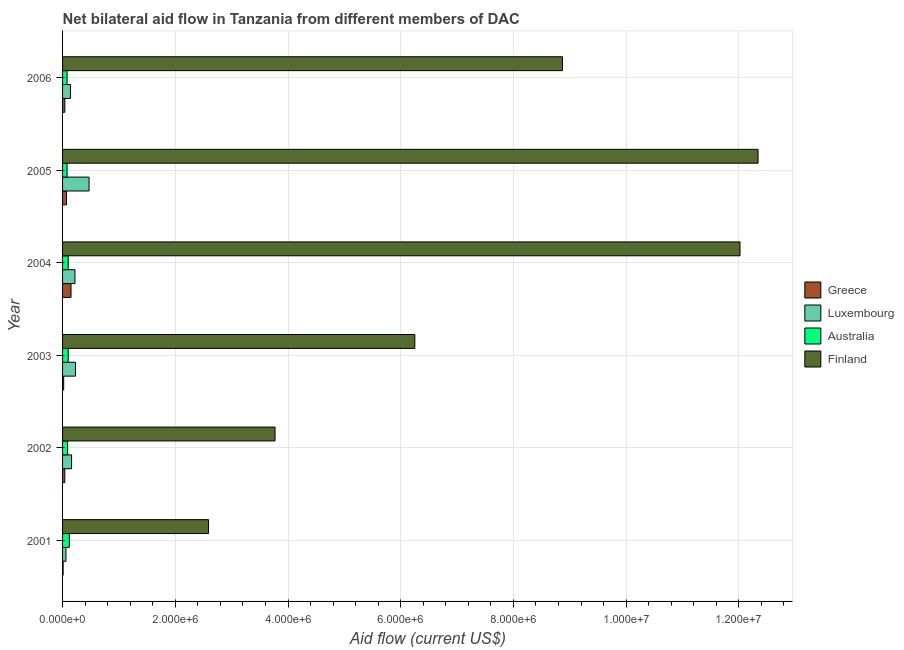Are the number of bars per tick equal to the number of legend labels?
Keep it short and to the point. Yes. Are the number of bars on each tick of the Y-axis equal?
Give a very brief answer. Yes. What is the amount of aid given by finland in 2005?
Keep it short and to the point. 1.23e+07. Across all years, what is the maximum amount of aid given by australia?
Your answer should be very brief. 1.20e+05. Across all years, what is the minimum amount of aid given by greece?
Provide a succinct answer. 10000. In which year was the amount of aid given by australia minimum?
Make the answer very short. 2005. What is the total amount of aid given by luxembourg in the graph?
Provide a short and direct response. 1.28e+06. What is the difference between the amount of aid given by finland in 2003 and that in 2005?
Provide a short and direct response. -6.09e+06. What is the difference between the amount of aid given by finland in 2004 and the amount of aid given by luxembourg in 2003?
Your answer should be compact. 1.18e+07. What is the average amount of aid given by luxembourg per year?
Your response must be concise. 2.13e+05. In the year 2001, what is the difference between the amount of aid given by finland and amount of aid given by luxembourg?
Offer a very short reply. 2.53e+06. What is the ratio of the amount of aid given by luxembourg in 2002 to that in 2003?
Your answer should be very brief. 0.7. Is the difference between the amount of aid given by greece in 2001 and 2005 greater than the difference between the amount of aid given by luxembourg in 2001 and 2005?
Your response must be concise. Yes. What is the difference between the highest and the second highest amount of aid given by luxembourg?
Make the answer very short. 2.40e+05. What is the difference between the highest and the lowest amount of aid given by luxembourg?
Your answer should be compact. 4.10e+05. In how many years, is the amount of aid given by greece greater than the average amount of aid given by greece taken over all years?
Offer a terse response. 2. Is the sum of the amount of aid given by australia in 2001 and 2004 greater than the maximum amount of aid given by luxembourg across all years?
Offer a very short reply. No. What does the 3rd bar from the top in 2004 represents?
Provide a short and direct response. Luxembourg. Is it the case that in every year, the sum of the amount of aid given by greece and amount of aid given by luxembourg is greater than the amount of aid given by australia?
Offer a terse response. No. Are all the bars in the graph horizontal?
Your answer should be very brief. Yes. Does the graph contain any zero values?
Offer a terse response. No. Does the graph contain grids?
Provide a short and direct response. Yes. How many legend labels are there?
Your answer should be compact. 4. How are the legend labels stacked?
Your response must be concise. Vertical. What is the title of the graph?
Your answer should be compact. Net bilateral aid flow in Tanzania from different members of DAC. What is the label or title of the X-axis?
Your answer should be compact. Aid flow (current US$). What is the Aid flow (current US$) in Australia in 2001?
Offer a very short reply. 1.20e+05. What is the Aid flow (current US$) of Finland in 2001?
Ensure brevity in your answer.  2.59e+06. What is the Aid flow (current US$) of Luxembourg in 2002?
Ensure brevity in your answer.  1.60e+05. What is the Aid flow (current US$) in Finland in 2002?
Your answer should be very brief. 3.77e+06. What is the Aid flow (current US$) in Luxembourg in 2003?
Offer a terse response. 2.30e+05. What is the Aid flow (current US$) of Australia in 2003?
Provide a short and direct response. 1.00e+05. What is the Aid flow (current US$) in Finland in 2003?
Provide a succinct answer. 6.25e+06. What is the Aid flow (current US$) of Finland in 2004?
Ensure brevity in your answer.  1.20e+07. What is the Aid flow (current US$) of Luxembourg in 2005?
Your answer should be compact. 4.70e+05. What is the Aid flow (current US$) in Finland in 2005?
Offer a very short reply. 1.23e+07. What is the Aid flow (current US$) in Luxembourg in 2006?
Your response must be concise. 1.40e+05. What is the Aid flow (current US$) of Australia in 2006?
Offer a terse response. 8.00e+04. What is the Aid flow (current US$) in Finland in 2006?
Ensure brevity in your answer.  8.87e+06. Across all years, what is the maximum Aid flow (current US$) in Finland?
Offer a terse response. 1.23e+07. Across all years, what is the minimum Aid flow (current US$) in Finland?
Your answer should be compact. 2.59e+06. What is the total Aid flow (current US$) in Luxembourg in the graph?
Make the answer very short. 1.28e+06. What is the total Aid flow (current US$) in Australia in the graph?
Offer a terse response. 5.70e+05. What is the total Aid flow (current US$) of Finland in the graph?
Keep it short and to the point. 4.58e+07. What is the difference between the Aid flow (current US$) in Greece in 2001 and that in 2002?
Make the answer very short. -3.00e+04. What is the difference between the Aid flow (current US$) in Australia in 2001 and that in 2002?
Ensure brevity in your answer.  3.00e+04. What is the difference between the Aid flow (current US$) in Finland in 2001 and that in 2002?
Provide a succinct answer. -1.18e+06. What is the difference between the Aid flow (current US$) of Australia in 2001 and that in 2003?
Provide a succinct answer. 2.00e+04. What is the difference between the Aid flow (current US$) of Finland in 2001 and that in 2003?
Offer a very short reply. -3.66e+06. What is the difference between the Aid flow (current US$) of Australia in 2001 and that in 2004?
Keep it short and to the point. 2.00e+04. What is the difference between the Aid flow (current US$) of Finland in 2001 and that in 2004?
Provide a succinct answer. -9.43e+06. What is the difference between the Aid flow (current US$) of Luxembourg in 2001 and that in 2005?
Your answer should be compact. -4.10e+05. What is the difference between the Aid flow (current US$) of Australia in 2001 and that in 2005?
Offer a terse response. 4.00e+04. What is the difference between the Aid flow (current US$) in Finland in 2001 and that in 2005?
Give a very brief answer. -9.75e+06. What is the difference between the Aid flow (current US$) of Greece in 2001 and that in 2006?
Give a very brief answer. -3.00e+04. What is the difference between the Aid flow (current US$) in Australia in 2001 and that in 2006?
Your answer should be very brief. 4.00e+04. What is the difference between the Aid flow (current US$) of Finland in 2001 and that in 2006?
Provide a short and direct response. -6.28e+06. What is the difference between the Aid flow (current US$) in Australia in 2002 and that in 2003?
Keep it short and to the point. -10000. What is the difference between the Aid flow (current US$) of Finland in 2002 and that in 2003?
Provide a succinct answer. -2.48e+06. What is the difference between the Aid flow (current US$) in Australia in 2002 and that in 2004?
Offer a very short reply. -10000. What is the difference between the Aid flow (current US$) of Finland in 2002 and that in 2004?
Ensure brevity in your answer.  -8.25e+06. What is the difference between the Aid flow (current US$) of Greece in 2002 and that in 2005?
Ensure brevity in your answer.  -3.00e+04. What is the difference between the Aid flow (current US$) in Luxembourg in 2002 and that in 2005?
Your answer should be very brief. -3.10e+05. What is the difference between the Aid flow (current US$) in Australia in 2002 and that in 2005?
Ensure brevity in your answer.  10000. What is the difference between the Aid flow (current US$) of Finland in 2002 and that in 2005?
Provide a short and direct response. -8.57e+06. What is the difference between the Aid flow (current US$) in Greece in 2002 and that in 2006?
Offer a very short reply. 0. What is the difference between the Aid flow (current US$) in Finland in 2002 and that in 2006?
Offer a very short reply. -5.10e+06. What is the difference between the Aid flow (current US$) in Greece in 2003 and that in 2004?
Give a very brief answer. -1.30e+05. What is the difference between the Aid flow (current US$) in Australia in 2003 and that in 2004?
Ensure brevity in your answer.  0. What is the difference between the Aid flow (current US$) of Finland in 2003 and that in 2004?
Provide a short and direct response. -5.77e+06. What is the difference between the Aid flow (current US$) in Greece in 2003 and that in 2005?
Offer a very short reply. -5.00e+04. What is the difference between the Aid flow (current US$) in Luxembourg in 2003 and that in 2005?
Ensure brevity in your answer.  -2.40e+05. What is the difference between the Aid flow (current US$) of Finland in 2003 and that in 2005?
Ensure brevity in your answer.  -6.09e+06. What is the difference between the Aid flow (current US$) of Luxembourg in 2003 and that in 2006?
Offer a very short reply. 9.00e+04. What is the difference between the Aid flow (current US$) of Australia in 2003 and that in 2006?
Offer a terse response. 2.00e+04. What is the difference between the Aid flow (current US$) in Finland in 2003 and that in 2006?
Provide a short and direct response. -2.62e+06. What is the difference between the Aid flow (current US$) in Greece in 2004 and that in 2005?
Offer a very short reply. 8.00e+04. What is the difference between the Aid flow (current US$) in Finland in 2004 and that in 2005?
Your answer should be compact. -3.20e+05. What is the difference between the Aid flow (current US$) in Greece in 2004 and that in 2006?
Make the answer very short. 1.10e+05. What is the difference between the Aid flow (current US$) of Australia in 2004 and that in 2006?
Your response must be concise. 2.00e+04. What is the difference between the Aid flow (current US$) of Finland in 2004 and that in 2006?
Ensure brevity in your answer.  3.15e+06. What is the difference between the Aid flow (current US$) in Greece in 2005 and that in 2006?
Make the answer very short. 3.00e+04. What is the difference between the Aid flow (current US$) of Luxembourg in 2005 and that in 2006?
Ensure brevity in your answer.  3.30e+05. What is the difference between the Aid flow (current US$) of Finland in 2005 and that in 2006?
Give a very brief answer. 3.47e+06. What is the difference between the Aid flow (current US$) in Greece in 2001 and the Aid flow (current US$) in Luxembourg in 2002?
Your answer should be compact. -1.50e+05. What is the difference between the Aid flow (current US$) in Greece in 2001 and the Aid flow (current US$) in Finland in 2002?
Ensure brevity in your answer.  -3.76e+06. What is the difference between the Aid flow (current US$) in Luxembourg in 2001 and the Aid flow (current US$) in Australia in 2002?
Offer a terse response. -3.00e+04. What is the difference between the Aid flow (current US$) in Luxembourg in 2001 and the Aid flow (current US$) in Finland in 2002?
Your answer should be very brief. -3.71e+06. What is the difference between the Aid flow (current US$) in Australia in 2001 and the Aid flow (current US$) in Finland in 2002?
Provide a succinct answer. -3.65e+06. What is the difference between the Aid flow (current US$) of Greece in 2001 and the Aid flow (current US$) of Luxembourg in 2003?
Provide a short and direct response. -2.20e+05. What is the difference between the Aid flow (current US$) in Greece in 2001 and the Aid flow (current US$) in Finland in 2003?
Make the answer very short. -6.24e+06. What is the difference between the Aid flow (current US$) in Luxembourg in 2001 and the Aid flow (current US$) in Finland in 2003?
Make the answer very short. -6.19e+06. What is the difference between the Aid flow (current US$) in Australia in 2001 and the Aid flow (current US$) in Finland in 2003?
Provide a short and direct response. -6.13e+06. What is the difference between the Aid flow (current US$) of Greece in 2001 and the Aid flow (current US$) of Finland in 2004?
Make the answer very short. -1.20e+07. What is the difference between the Aid flow (current US$) of Luxembourg in 2001 and the Aid flow (current US$) of Finland in 2004?
Offer a very short reply. -1.20e+07. What is the difference between the Aid flow (current US$) in Australia in 2001 and the Aid flow (current US$) in Finland in 2004?
Provide a short and direct response. -1.19e+07. What is the difference between the Aid flow (current US$) in Greece in 2001 and the Aid flow (current US$) in Luxembourg in 2005?
Provide a succinct answer. -4.60e+05. What is the difference between the Aid flow (current US$) of Greece in 2001 and the Aid flow (current US$) of Finland in 2005?
Your response must be concise. -1.23e+07. What is the difference between the Aid flow (current US$) of Luxembourg in 2001 and the Aid flow (current US$) of Australia in 2005?
Give a very brief answer. -2.00e+04. What is the difference between the Aid flow (current US$) in Luxembourg in 2001 and the Aid flow (current US$) in Finland in 2005?
Keep it short and to the point. -1.23e+07. What is the difference between the Aid flow (current US$) of Australia in 2001 and the Aid flow (current US$) of Finland in 2005?
Your response must be concise. -1.22e+07. What is the difference between the Aid flow (current US$) in Greece in 2001 and the Aid flow (current US$) in Luxembourg in 2006?
Provide a short and direct response. -1.30e+05. What is the difference between the Aid flow (current US$) of Greece in 2001 and the Aid flow (current US$) of Finland in 2006?
Your answer should be compact. -8.86e+06. What is the difference between the Aid flow (current US$) in Luxembourg in 2001 and the Aid flow (current US$) in Australia in 2006?
Your answer should be compact. -2.00e+04. What is the difference between the Aid flow (current US$) in Luxembourg in 2001 and the Aid flow (current US$) in Finland in 2006?
Provide a short and direct response. -8.81e+06. What is the difference between the Aid flow (current US$) in Australia in 2001 and the Aid flow (current US$) in Finland in 2006?
Provide a succinct answer. -8.75e+06. What is the difference between the Aid flow (current US$) in Greece in 2002 and the Aid flow (current US$) in Finland in 2003?
Keep it short and to the point. -6.21e+06. What is the difference between the Aid flow (current US$) in Luxembourg in 2002 and the Aid flow (current US$) in Finland in 2003?
Offer a very short reply. -6.09e+06. What is the difference between the Aid flow (current US$) of Australia in 2002 and the Aid flow (current US$) of Finland in 2003?
Provide a short and direct response. -6.16e+06. What is the difference between the Aid flow (current US$) in Greece in 2002 and the Aid flow (current US$) in Finland in 2004?
Give a very brief answer. -1.20e+07. What is the difference between the Aid flow (current US$) in Luxembourg in 2002 and the Aid flow (current US$) in Australia in 2004?
Offer a terse response. 6.00e+04. What is the difference between the Aid flow (current US$) in Luxembourg in 2002 and the Aid flow (current US$) in Finland in 2004?
Provide a short and direct response. -1.19e+07. What is the difference between the Aid flow (current US$) of Australia in 2002 and the Aid flow (current US$) of Finland in 2004?
Offer a terse response. -1.19e+07. What is the difference between the Aid flow (current US$) in Greece in 2002 and the Aid flow (current US$) in Luxembourg in 2005?
Keep it short and to the point. -4.30e+05. What is the difference between the Aid flow (current US$) in Greece in 2002 and the Aid flow (current US$) in Finland in 2005?
Provide a short and direct response. -1.23e+07. What is the difference between the Aid flow (current US$) of Luxembourg in 2002 and the Aid flow (current US$) of Finland in 2005?
Ensure brevity in your answer.  -1.22e+07. What is the difference between the Aid flow (current US$) in Australia in 2002 and the Aid flow (current US$) in Finland in 2005?
Keep it short and to the point. -1.22e+07. What is the difference between the Aid flow (current US$) in Greece in 2002 and the Aid flow (current US$) in Finland in 2006?
Make the answer very short. -8.83e+06. What is the difference between the Aid flow (current US$) in Luxembourg in 2002 and the Aid flow (current US$) in Finland in 2006?
Offer a terse response. -8.71e+06. What is the difference between the Aid flow (current US$) in Australia in 2002 and the Aid flow (current US$) in Finland in 2006?
Ensure brevity in your answer.  -8.78e+06. What is the difference between the Aid flow (current US$) in Greece in 2003 and the Aid flow (current US$) in Australia in 2004?
Offer a very short reply. -8.00e+04. What is the difference between the Aid flow (current US$) of Greece in 2003 and the Aid flow (current US$) of Finland in 2004?
Your answer should be very brief. -1.20e+07. What is the difference between the Aid flow (current US$) in Luxembourg in 2003 and the Aid flow (current US$) in Australia in 2004?
Ensure brevity in your answer.  1.30e+05. What is the difference between the Aid flow (current US$) of Luxembourg in 2003 and the Aid flow (current US$) of Finland in 2004?
Your answer should be compact. -1.18e+07. What is the difference between the Aid flow (current US$) of Australia in 2003 and the Aid flow (current US$) of Finland in 2004?
Your answer should be very brief. -1.19e+07. What is the difference between the Aid flow (current US$) of Greece in 2003 and the Aid flow (current US$) of Luxembourg in 2005?
Provide a succinct answer. -4.50e+05. What is the difference between the Aid flow (current US$) of Greece in 2003 and the Aid flow (current US$) of Finland in 2005?
Ensure brevity in your answer.  -1.23e+07. What is the difference between the Aid flow (current US$) in Luxembourg in 2003 and the Aid flow (current US$) in Australia in 2005?
Keep it short and to the point. 1.50e+05. What is the difference between the Aid flow (current US$) of Luxembourg in 2003 and the Aid flow (current US$) of Finland in 2005?
Your response must be concise. -1.21e+07. What is the difference between the Aid flow (current US$) in Australia in 2003 and the Aid flow (current US$) in Finland in 2005?
Offer a very short reply. -1.22e+07. What is the difference between the Aid flow (current US$) in Greece in 2003 and the Aid flow (current US$) in Luxembourg in 2006?
Your answer should be very brief. -1.20e+05. What is the difference between the Aid flow (current US$) of Greece in 2003 and the Aid flow (current US$) of Finland in 2006?
Offer a very short reply. -8.85e+06. What is the difference between the Aid flow (current US$) in Luxembourg in 2003 and the Aid flow (current US$) in Finland in 2006?
Provide a short and direct response. -8.64e+06. What is the difference between the Aid flow (current US$) of Australia in 2003 and the Aid flow (current US$) of Finland in 2006?
Provide a succinct answer. -8.77e+06. What is the difference between the Aid flow (current US$) of Greece in 2004 and the Aid flow (current US$) of Luxembourg in 2005?
Provide a succinct answer. -3.20e+05. What is the difference between the Aid flow (current US$) in Greece in 2004 and the Aid flow (current US$) in Finland in 2005?
Keep it short and to the point. -1.22e+07. What is the difference between the Aid flow (current US$) of Luxembourg in 2004 and the Aid flow (current US$) of Australia in 2005?
Give a very brief answer. 1.40e+05. What is the difference between the Aid flow (current US$) in Luxembourg in 2004 and the Aid flow (current US$) in Finland in 2005?
Provide a short and direct response. -1.21e+07. What is the difference between the Aid flow (current US$) in Australia in 2004 and the Aid flow (current US$) in Finland in 2005?
Your answer should be very brief. -1.22e+07. What is the difference between the Aid flow (current US$) in Greece in 2004 and the Aid flow (current US$) in Finland in 2006?
Give a very brief answer. -8.72e+06. What is the difference between the Aid flow (current US$) in Luxembourg in 2004 and the Aid flow (current US$) in Australia in 2006?
Offer a very short reply. 1.40e+05. What is the difference between the Aid flow (current US$) of Luxembourg in 2004 and the Aid flow (current US$) of Finland in 2006?
Keep it short and to the point. -8.65e+06. What is the difference between the Aid flow (current US$) in Australia in 2004 and the Aid flow (current US$) in Finland in 2006?
Make the answer very short. -8.77e+06. What is the difference between the Aid flow (current US$) of Greece in 2005 and the Aid flow (current US$) of Finland in 2006?
Make the answer very short. -8.80e+06. What is the difference between the Aid flow (current US$) of Luxembourg in 2005 and the Aid flow (current US$) of Finland in 2006?
Keep it short and to the point. -8.40e+06. What is the difference between the Aid flow (current US$) in Australia in 2005 and the Aid flow (current US$) in Finland in 2006?
Make the answer very short. -8.79e+06. What is the average Aid flow (current US$) in Greece per year?
Your response must be concise. 5.50e+04. What is the average Aid flow (current US$) of Luxembourg per year?
Ensure brevity in your answer.  2.13e+05. What is the average Aid flow (current US$) of Australia per year?
Your answer should be compact. 9.50e+04. What is the average Aid flow (current US$) of Finland per year?
Give a very brief answer. 7.64e+06. In the year 2001, what is the difference between the Aid flow (current US$) of Greece and Aid flow (current US$) of Australia?
Offer a terse response. -1.10e+05. In the year 2001, what is the difference between the Aid flow (current US$) of Greece and Aid flow (current US$) of Finland?
Offer a very short reply. -2.58e+06. In the year 2001, what is the difference between the Aid flow (current US$) in Luxembourg and Aid flow (current US$) in Australia?
Your response must be concise. -6.00e+04. In the year 2001, what is the difference between the Aid flow (current US$) of Luxembourg and Aid flow (current US$) of Finland?
Offer a terse response. -2.53e+06. In the year 2001, what is the difference between the Aid flow (current US$) of Australia and Aid flow (current US$) of Finland?
Keep it short and to the point. -2.47e+06. In the year 2002, what is the difference between the Aid flow (current US$) of Greece and Aid flow (current US$) of Luxembourg?
Give a very brief answer. -1.20e+05. In the year 2002, what is the difference between the Aid flow (current US$) in Greece and Aid flow (current US$) in Finland?
Provide a succinct answer. -3.73e+06. In the year 2002, what is the difference between the Aid flow (current US$) in Luxembourg and Aid flow (current US$) in Australia?
Make the answer very short. 7.00e+04. In the year 2002, what is the difference between the Aid flow (current US$) of Luxembourg and Aid flow (current US$) of Finland?
Your response must be concise. -3.61e+06. In the year 2002, what is the difference between the Aid flow (current US$) of Australia and Aid flow (current US$) of Finland?
Give a very brief answer. -3.68e+06. In the year 2003, what is the difference between the Aid flow (current US$) of Greece and Aid flow (current US$) of Australia?
Offer a terse response. -8.00e+04. In the year 2003, what is the difference between the Aid flow (current US$) of Greece and Aid flow (current US$) of Finland?
Give a very brief answer. -6.23e+06. In the year 2003, what is the difference between the Aid flow (current US$) of Luxembourg and Aid flow (current US$) of Finland?
Make the answer very short. -6.02e+06. In the year 2003, what is the difference between the Aid flow (current US$) of Australia and Aid flow (current US$) of Finland?
Your answer should be compact. -6.15e+06. In the year 2004, what is the difference between the Aid flow (current US$) in Greece and Aid flow (current US$) in Luxembourg?
Your answer should be very brief. -7.00e+04. In the year 2004, what is the difference between the Aid flow (current US$) in Greece and Aid flow (current US$) in Australia?
Your answer should be very brief. 5.00e+04. In the year 2004, what is the difference between the Aid flow (current US$) in Greece and Aid flow (current US$) in Finland?
Offer a terse response. -1.19e+07. In the year 2004, what is the difference between the Aid flow (current US$) of Luxembourg and Aid flow (current US$) of Finland?
Your answer should be compact. -1.18e+07. In the year 2004, what is the difference between the Aid flow (current US$) in Australia and Aid flow (current US$) in Finland?
Offer a very short reply. -1.19e+07. In the year 2005, what is the difference between the Aid flow (current US$) in Greece and Aid flow (current US$) in Luxembourg?
Provide a succinct answer. -4.00e+05. In the year 2005, what is the difference between the Aid flow (current US$) of Greece and Aid flow (current US$) of Australia?
Your answer should be compact. -10000. In the year 2005, what is the difference between the Aid flow (current US$) in Greece and Aid flow (current US$) in Finland?
Offer a terse response. -1.23e+07. In the year 2005, what is the difference between the Aid flow (current US$) in Luxembourg and Aid flow (current US$) in Australia?
Ensure brevity in your answer.  3.90e+05. In the year 2005, what is the difference between the Aid flow (current US$) of Luxembourg and Aid flow (current US$) of Finland?
Give a very brief answer. -1.19e+07. In the year 2005, what is the difference between the Aid flow (current US$) of Australia and Aid flow (current US$) of Finland?
Provide a short and direct response. -1.23e+07. In the year 2006, what is the difference between the Aid flow (current US$) in Greece and Aid flow (current US$) in Finland?
Provide a short and direct response. -8.83e+06. In the year 2006, what is the difference between the Aid flow (current US$) in Luxembourg and Aid flow (current US$) in Australia?
Give a very brief answer. 6.00e+04. In the year 2006, what is the difference between the Aid flow (current US$) of Luxembourg and Aid flow (current US$) of Finland?
Your response must be concise. -8.73e+06. In the year 2006, what is the difference between the Aid flow (current US$) in Australia and Aid flow (current US$) in Finland?
Give a very brief answer. -8.79e+06. What is the ratio of the Aid flow (current US$) in Greece in 2001 to that in 2002?
Provide a short and direct response. 0.25. What is the ratio of the Aid flow (current US$) in Finland in 2001 to that in 2002?
Keep it short and to the point. 0.69. What is the ratio of the Aid flow (current US$) of Luxembourg in 2001 to that in 2003?
Keep it short and to the point. 0.26. What is the ratio of the Aid flow (current US$) in Australia in 2001 to that in 2003?
Make the answer very short. 1.2. What is the ratio of the Aid flow (current US$) of Finland in 2001 to that in 2003?
Make the answer very short. 0.41. What is the ratio of the Aid flow (current US$) of Greece in 2001 to that in 2004?
Ensure brevity in your answer.  0.07. What is the ratio of the Aid flow (current US$) in Luxembourg in 2001 to that in 2004?
Your answer should be compact. 0.27. What is the ratio of the Aid flow (current US$) of Australia in 2001 to that in 2004?
Your answer should be very brief. 1.2. What is the ratio of the Aid flow (current US$) of Finland in 2001 to that in 2004?
Provide a short and direct response. 0.22. What is the ratio of the Aid flow (current US$) of Greece in 2001 to that in 2005?
Provide a succinct answer. 0.14. What is the ratio of the Aid flow (current US$) in Luxembourg in 2001 to that in 2005?
Provide a succinct answer. 0.13. What is the ratio of the Aid flow (current US$) in Australia in 2001 to that in 2005?
Offer a very short reply. 1.5. What is the ratio of the Aid flow (current US$) of Finland in 2001 to that in 2005?
Offer a very short reply. 0.21. What is the ratio of the Aid flow (current US$) in Greece in 2001 to that in 2006?
Ensure brevity in your answer.  0.25. What is the ratio of the Aid flow (current US$) of Luxembourg in 2001 to that in 2006?
Ensure brevity in your answer.  0.43. What is the ratio of the Aid flow (current US$) of Finland in 2001 to that in 2006?
Keep it short and to the point. 0.29. What is the ratio of the Aid flow (current US$) of Luxembourg in 2002 to that in 2003?
Provide a short and direct response. 0.7. What is the ratio of the Aid flow (current US$) of Finland in 2002 to that in 2003?
Provide a short and direct response. 0.6. What is the ratio of the Aid flow (current US$) of Greece in 2002 to that in 2004?
Your answer should be very brief. 0.27. What is the ratio of the Aid flow (current US$) of Luxembourg in 2002 to that in 2004?
Your response must be concise. 0.73. What is the ratio of the Aid flow (current US$) of Finland in 2002 to that in 2004?
Keep it short and to the point. 0.31. What is the ratio of the Aid flow (current US$) in Greece in 2002 to that in 2005?
Your response must be concise. 0.57. What is the ratio of the Aid flow (current US$) of Luxembourg in 2002 to that in 2005?
Make the answer very short. 0.34. What is the ratio of the Aid flow (current US$) of Australia in 2002 to that in 2005?
Ensure brevity in your answer.  1.12. What is the ratio of the Aid flow (current US$) of Finland in 2002 to that in 2005?
Offer a very short reply. 0.31. What is the ratio of the Aid flow (current US$) of Greece in 2002 to that in 2006?
Your answer should be compact. 1. What is the ratio of the Aid flow (current US$) of Luxembourg in 2002 to that in 2006?
Give a very brief answer. 1.14. What is the ratio of the Aid flow (current US$) of Finland in 2002 to that in 2006?
Your answer should be very brief. 0.42. What is the ratio of the Aid flow (current US$) of Greece in 2003 to that in 2004?
Make the answer very short. 0.13. What is the ratio of the Aid flow (current US$) of Luxembourg in 2003 to that in 2004?
Your answer should be compact. 1.05. What is the ratio of the Aid flow (current US$) of Australia in 2003 to that in 2004?
Make the answer very short. 1. What is the ratio of the Aid flow (current US$) in Finland in 2003 to that in 2004?
Provide a short and direct response. 0.52. What is the ratio of the Aid flow (current US$) in Greece in 2003 to that in 2005?
Provide a succinct answer. 0.29. What is the ratio of the Aid flow (current US$) of Luxembourg in 2003 to that in 2005?
Provide a short and direct response. 0.49. What is the ratio of the Aid flow (current US$) in Finland in 2003 to that in 2005?
Make the answer very short. 0.51. What is the ratio of the Aid flow (current US$) in Greece in 2003 to that in 2006?
Provide a succinct answer. 0.5. What is the ratio of the Aid flow (current US$) of Luxembourg in 2003 to that in 2006?
Provide a short and direct response. 1.64. What is the ratio of the Aid flow (current US$) of Australia in 2003 to that in 2006?
Give a very brief answer. 1.25. What is the ratio of the Aid flow (current US$) in Finland in 2003 to that in 2006?
Your response must be concise. 0.7. What is the ratio of the Aid flow (current US$) of Greece in 2004 to that in 2005?
Keep it short and to the point. 2.14. What is the ratio of the Aid flow (current US$) of Luxembourg in 2004 to that in 2005?
Your response must be concise. 0.47. What is the ratio of the Aid flow (current US$) in Finland in 2004 to that in 2005?
Make the answer very short. 0.97. What is the ratio of the Aid flow (current US$) in Greece in 2004 to that in 2006?
Keep it short and to the point. 3.75. What is the ratio of the Aid flow (current US$) in Luxembourg in 2004 to that in 2006?
Give a very brief answer. 1.57. What is the ratio of the Aid flow (current US$) of Finland in 2004 to that in 2006?
Give a very brief answer. 1.36. What is the ratio of the Aid flow (current US$) of Greece in 2005 to that in 2006?
Give a very brief answer. 1.75. What is the ratio of the Aid flow (current US$) in Luxembourg in 2005 to that in 2006?
Offer a terse response. 3.36. What is the ratio of the Aid flow (current US$) in Australia in 2005 to that in 2006?
Your response must be concise. 1. What is the ratio of the Aid flow (current US$) of Finland in 2005 to that in 2006?
Provide a short and direct response. 1.39. What is the difference between the highest and the second highest Aid flow (current US$) in Luxembourg?
Keep it short and to the point. 2.40e+05. What is the difference between the highest and the second highest Aid flow (current US$) in Australia?
Your answer should be compact. 2.00e+04. What is the difference between the highest and the second highest Aid flow (current US$) of Finland?
Your response must be concise. 3.20e+05. What is the difference between the highest and the lowest Aid flow (current US$) of Greece?
Offer a terse response. 1.40e+05. What is the difference between the highest and the lowest Aid flow (current US$) in Luxembourg?
Provide a short and direct response. 4.10e+05. What is the difference between the highest and the lowest Aid flow (current US$) of Finland?
Make the answer very short. 9.75e+06. 